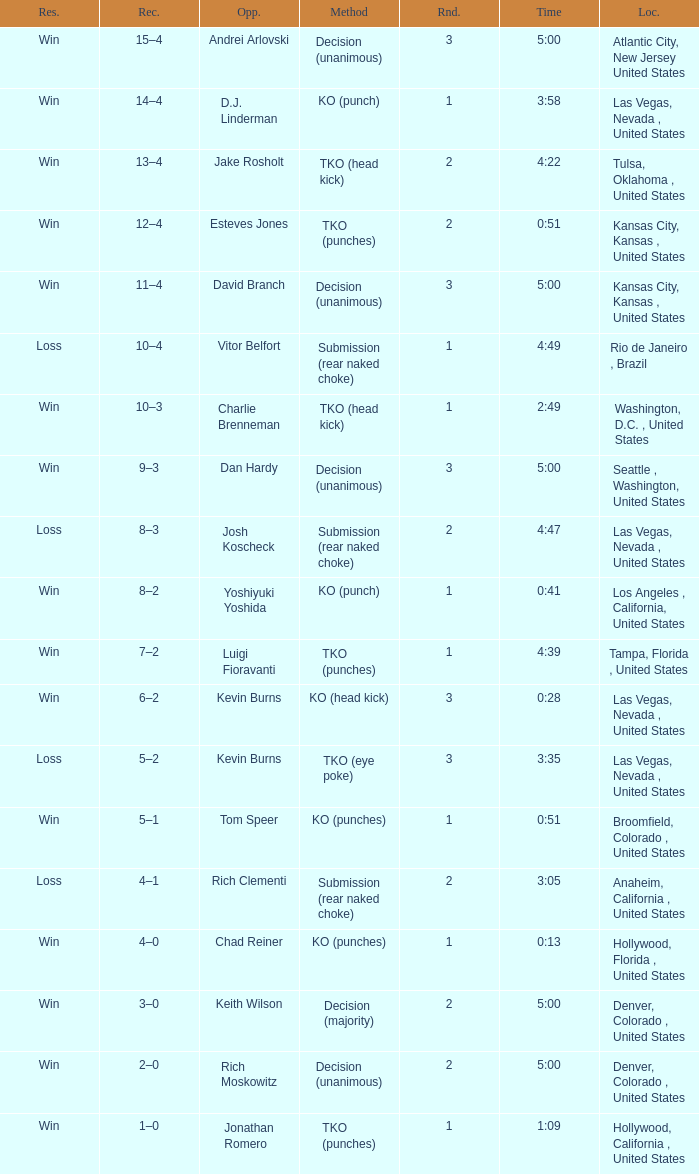Which record has a time of 0:13? 4–0. 